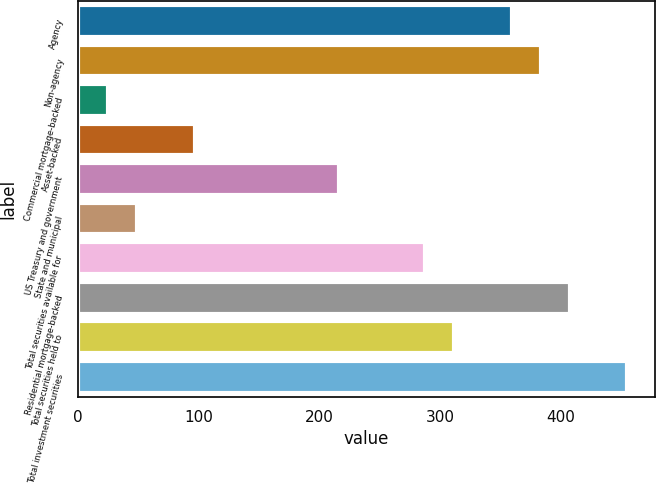Convert chart. <chart><loc_0><loc_0><loc_500><loc_500><bar_chart><fcel>Agency<fcel>Non-agency<fcel>Commercial mortgage-backed<fcel>Asset-backed<fcel>US Treasury and government<fcel>State and municipal<fcel>Total securities available for<fcel>Residential mortgage-backed<fcel>Total securities held to<fcel>Total investment securities<nl><fcel>359.5<fcel>383.4<fcel>24.9<fcel>96.6<fcel>216.1<fcel>48.8<fcel>287.8<fcel>407.3<fcel>311.7<fcel>455.1<nl></chart> 